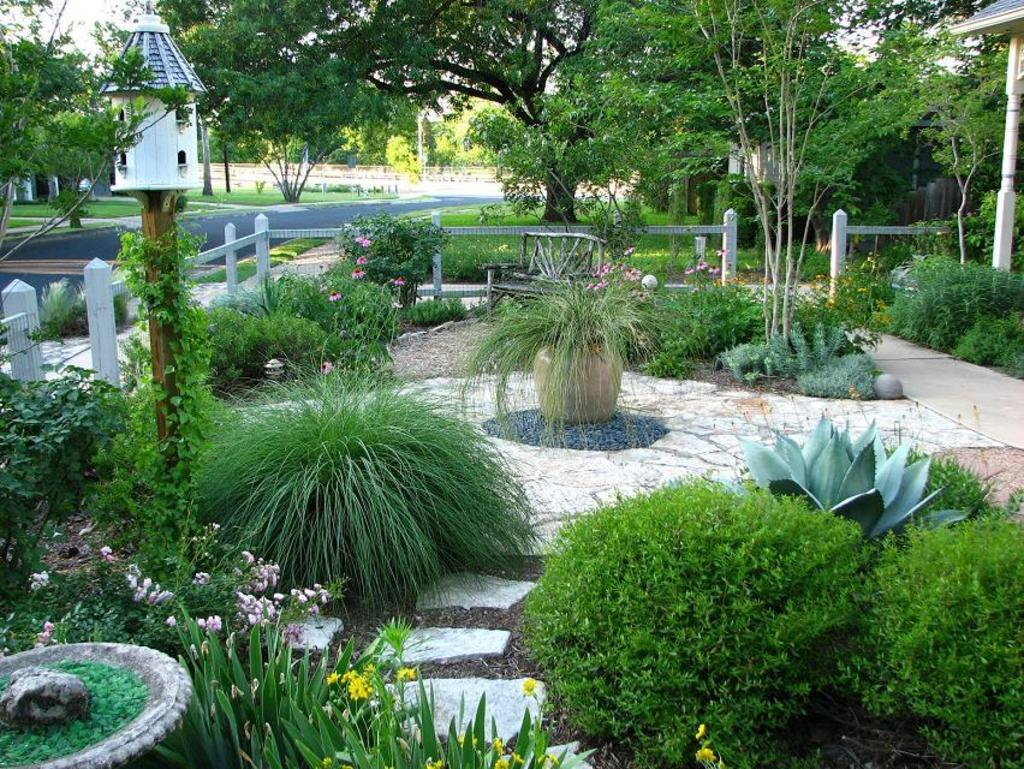What type of living organisms can be seen in the image? Plants and flowers are visible in the image. What is the purpose of the fencing in the image? The purpose of the fencing is not explicitly stated, but it may be used to enclose or separate areas. What can be seen in the background of the image? There is a road, houses, and trees visible in the background of the image. What type of suit is the plant wearing in the image? There is no suit present in the image, as plants do not wear clothing. What type of produce is being harvested from the plants in the image? There is no produce being harvested in the image, as the plants are not depicted as being cultivated for food. 